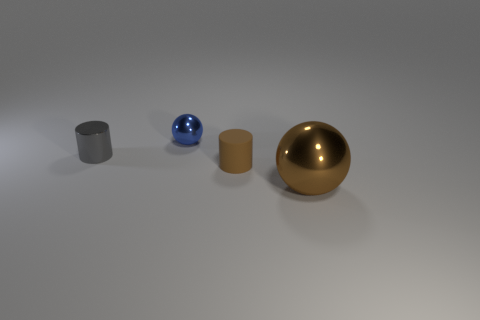Does the small blue thing have the same material as the gray cylinder that is to the left of the tiny blue metallic thing?
Give a very brief answer. Yes. The rubber cylinder has what color?
Your answer should be compact. Brown. There is a metallic sphere that is in front of the cylinder left of the ball that is on the left side of the big brown metallic object; what is its color?
Ensure brevity in your answer.  Brown. There is a big brown metal thing; does it have the same shape as the tiny metal object behind the gray thing?
Offer a very short reply. Yes. What is the color of the metal thing that is both on the right side of the gray cylinder and behind the rubber object?
Offer a very short reply. Blue. Is there a tiny brown object of the same shape as the big brown thing?
Ensure brevity in your answer.  No. Does the big metal object have the same color as the small rubber cylinder?
Ensure brevity in your answer.  Yes. Is there a ball in front of the tiny cylinder that is left of the blue ball?
Offer a terse response. Yes. How many things are either cylinders that are to the left of the small brown object or small things that are to the right of the tiny shiny sphere?
Offer a terse response. 2. What number of things are either tiny blue balls or brown objects that are in front of the small brown object?
Your answer should be compact. 2. 